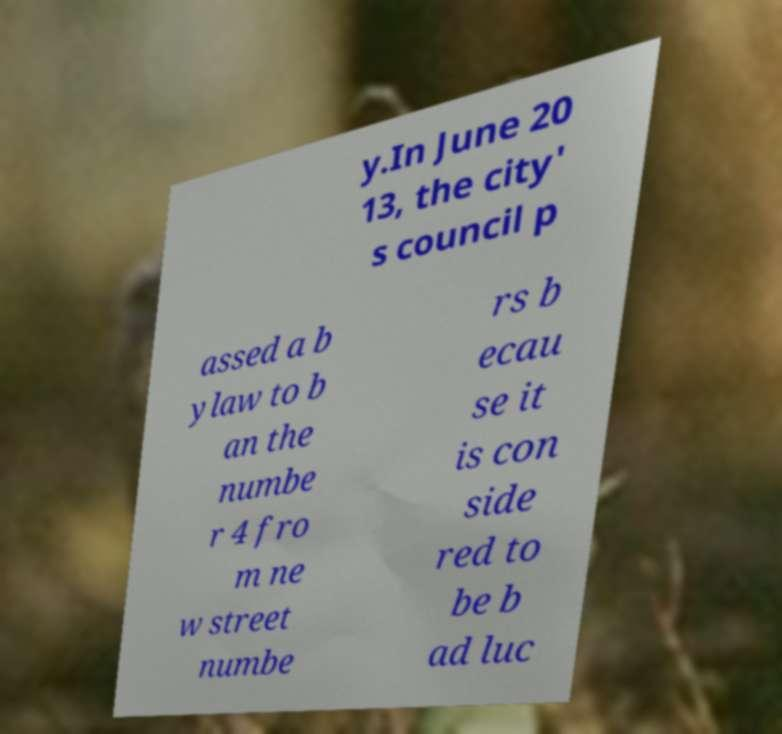What messages or text are displayed in this image? I need them in a readable, typed format. y.In June 20 13, the city' s council p assed a b ylaw to b an the numbe r 4 fro m ne w street numbe rs b ecau se it is con side red to be b ad luc 